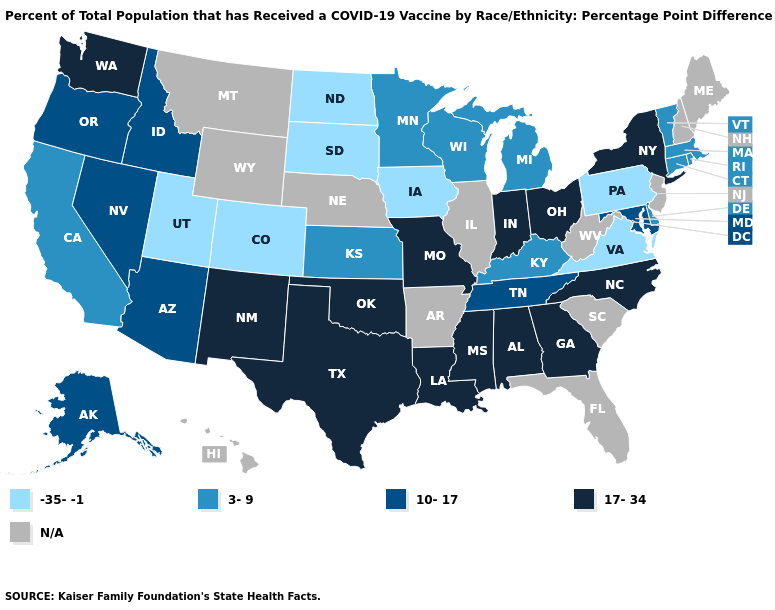What is the lowest value in the USA?
Short answer required. -35--1. Name the states that have a value in the range N/A?
Keep it brief. Arkansas, Florida, Hawaii, Illinois, Maine, Montana, Nebraska, New Hampshire, New Jersey, South Carolina, West Virginia, Wyoming. Does Virginia have the lowest value in the USA?
Give a very brief answer. Yes. Does Pennsylvania have the lowest value in the USA?
Concise answer only. Yes. What is the value of Arizona?
Concise answer only. 10-17. Name the states that have a value in the range 3-9?
Quick response, please. California, Connecticut, Delaware, Kansas, Kentucky, Massachusetts, Michigan, Minnesota, Rhode Island, Vermont, Wisconsin. Does Kansas have the highest value in the MidWest?
Give a very brief answer. No. What is the value of Illinois?
Give a very brief answer. N/A. What is the highest value in the USA?
Be succinct. 17-34. Does New Mexico have the lowest value in the West?
Be succinct. No. Is the legend a continuous bar?
Answer briefly. No. Does Kentucky have the highest value in the USA?
Keep it brief. No. Does Texas have the highest value in the USA?
Be succinct. Yes. Name the states that have a value in the range -35--1?
Quick response, please. Colorado, Iowa, North Dakota, Pennsylvania, South Dakota, Utah, Virginia. What is the highest value in the Northeast ?
Write a very short answer. 17-34. 